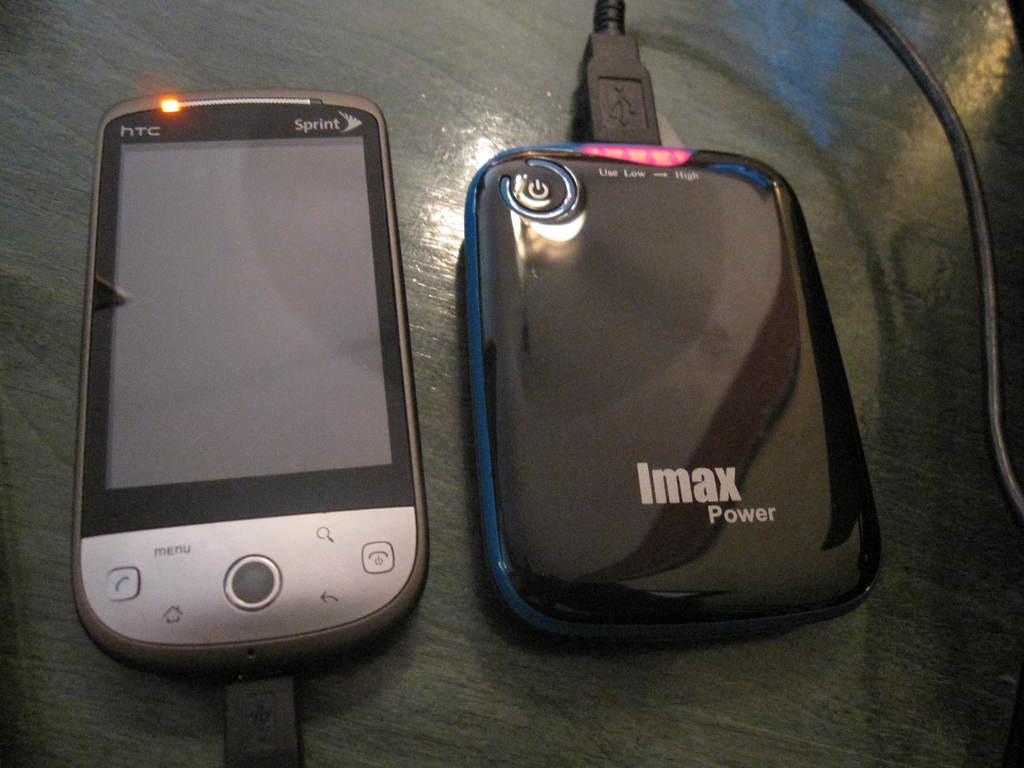<image>
Write a terse but informative summary of the picture. An HTC smart phone connected to an Imax power battery. 